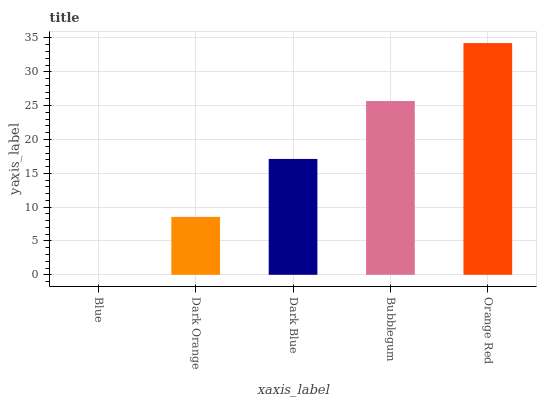Is Blue the minimum?
Answer yes or no. Yes. Is Orange Red the maximum?
Answer yes or no. Yes. Is Dark Orange the minimum?
Answer yes or no. No. Is Dark Orange the maximum?
Answer yes or no. No. Is Dark Orange greater than Blue?
Answer yes or no. Yes. Is Blue less than Dark Orange?
Answer yes or no. Yes. Is Blue greater than Dark Orange?
Answer yes or no. No. Is Dark Orange less than Blue?
Answer yes or no. No. Is Dark Blue the high median?
Answer yes or no. Yes. Is Dark Blue the low median?
Answer yes or no. Yes. Is Bubblegum the high median?
Answer yes or no. No. Is Blue the low median?
Answer yes or no. No. 